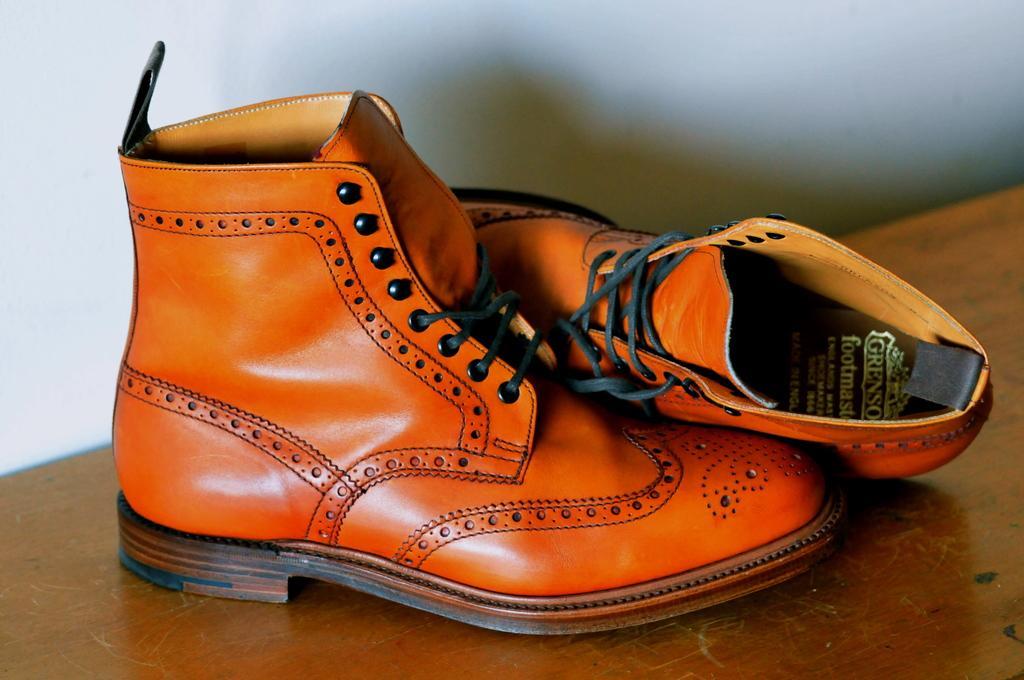How would you summarize this image in a sentence or two? This picture shows a pair of brown color shoes on the table. 